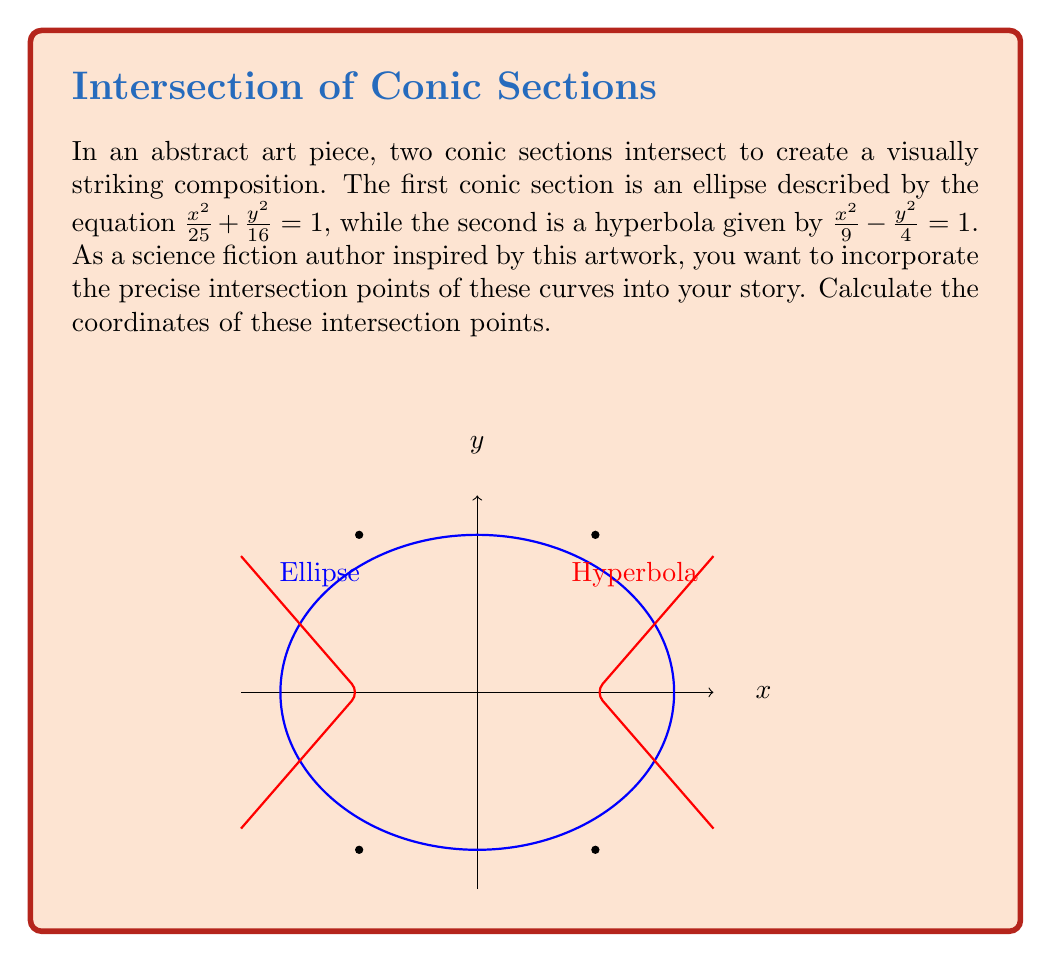Teach me how to tackle this problem. To find the intersection points, we need to solve the system of equations:

$$\frac{x^2}{25} + \frac{y^2}{16} = 1 \quad \text{(Ellipse)}$$
$$\frac{x^2}{9} - \frac{y^2}{4} = 1 \quad \text{(Hyperbola)}$$

Step 1: Multiply the ellipse equation by 16 and the hyperbola equation by 4:
$$\frac{16x^2}{25} + y^2 = 16$$
$$\frac{4x^2}{9} - y^2 = 4$$

Step 2: Add these equations to eliminate $y^2$:
$$\frac{16x^2}{25} + \frac{4x^2}{9} = 20$$

Step 3: Find a common denominator and simplify:
$$\frac{144x^2 + 100x^2}{225} = 20$$
$$\frac{244x^2}{225} = 20$$

Step 4: Solve for $x^2$:
$$x^2 = \frac{20 \cdot 225}{244} = \frac{4500}{244} = \frac{1125}{61} = 9$$

Step 5: Solve for $x$:
$$x = \pm 3$$

Step 6: Substitute these $x$ values into either original equation to find $y$. Let's use the ellipse equation:

For $x = 3$:
$$\frac{9}{25} + \frac{y^2}{16} = 1$$
$$\frac{y^2}{16} = \frac{16}{25}$$
$$y^2 = \frac{256}{25} = \frac{1024}{100} = 16$$
$$y = \pm 4$$

Step 7: Combine the $x$ and $y$ values to get the four intersection points:
$$(3, 4), (3, -4), (-3, 4), (-3, -4)$$
Answer: $(3, 4)$, $(3, -4)$, $(-3, 4)$, $(-3, -4)$ 